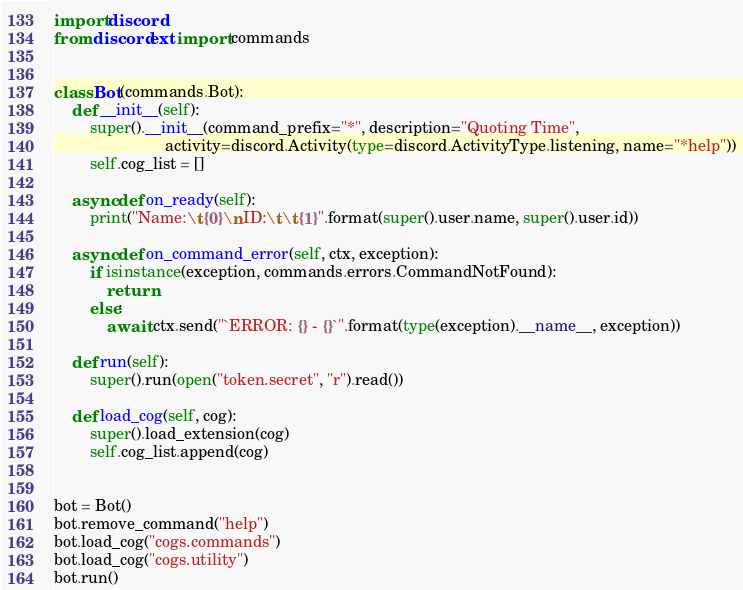<code> <loc_0><loc_0><loc_500><loc_500><_Python_>import discord
from discord.ext import commands


class Bot(commands.Bot):
    def __init__(self):
        super().__init__(command_prefix="*", description="Quoting Time",
                         activity=discord.Activity(type=discord.ActivityType.listening, name="*help"))
        self.cog_list = []

    async def on_ready(self):
        print("Name:\t{0}\nID:\t\t{1}".format(super().user.name, super().user.id))

    async def on_command_error(self, ctx, exception):
        if isinstance(exception, commands.errors.CommandNotFound):
            return
        else:
            await ctx.send("`ERROR: {} - {}`".format(type(exception).__name__, exception))

    def run(self):
        super().run(open("token.secret", "r").read())

    def load_cog(self, cog):
        super().load_extension(cog)
        self.cog_list.append(cog)


bot = Bot()
bot.remove_command("help")
bot.load_cog("cogs.commands")
bot.load_cog("cogs.utility")
bot.run()
</code> 